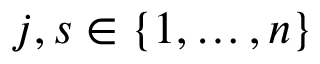Convert formula to latex. <formula><loc_0><loc_0><loc_500><loc_500>j , s \in \{ 1 , \dots , n \}</formula> 